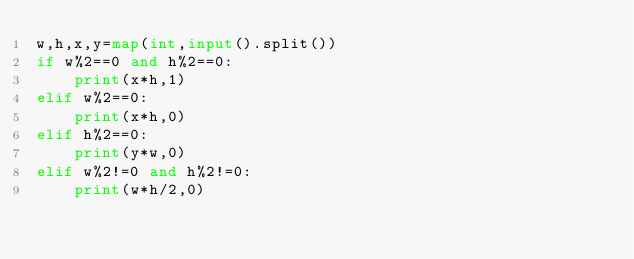Convert code to text. <code><loc_0><loc_0><loc_500><loc_500><_Python_>w,h,x,y=map(int,input().split())
if w%2==0 and h%2==0:
    print(x*h,1) 
elif w%2==0:
    print(x*h,0)
elif h%2==0:
    print(y*w,0)
elif w%2!=0 and h%2!=0:
    print(w*h/2,0)</code> 